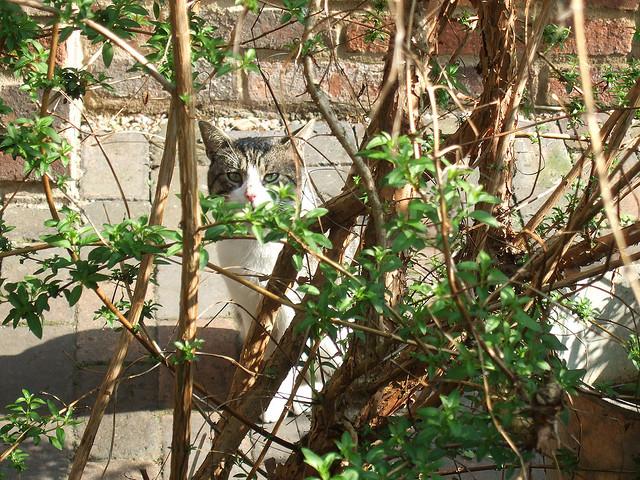Is this kitty climbing the tree?
Write a very short answer. No. What animal is peaking through the tree?
Quick response, please. Cat. Is there a bird?
Concise answer only. No. Is this a garden?
Be succinct. No. What animal is in the picture?
Be succinct. Cat. Is this the jungle?
Give a very brief answer. No. Is this taken during the day?
Quick response, please. Yes. What kind of natural setting is this?
Short answer required. Tree. Which color is dominant?
Short answer required. Green. 